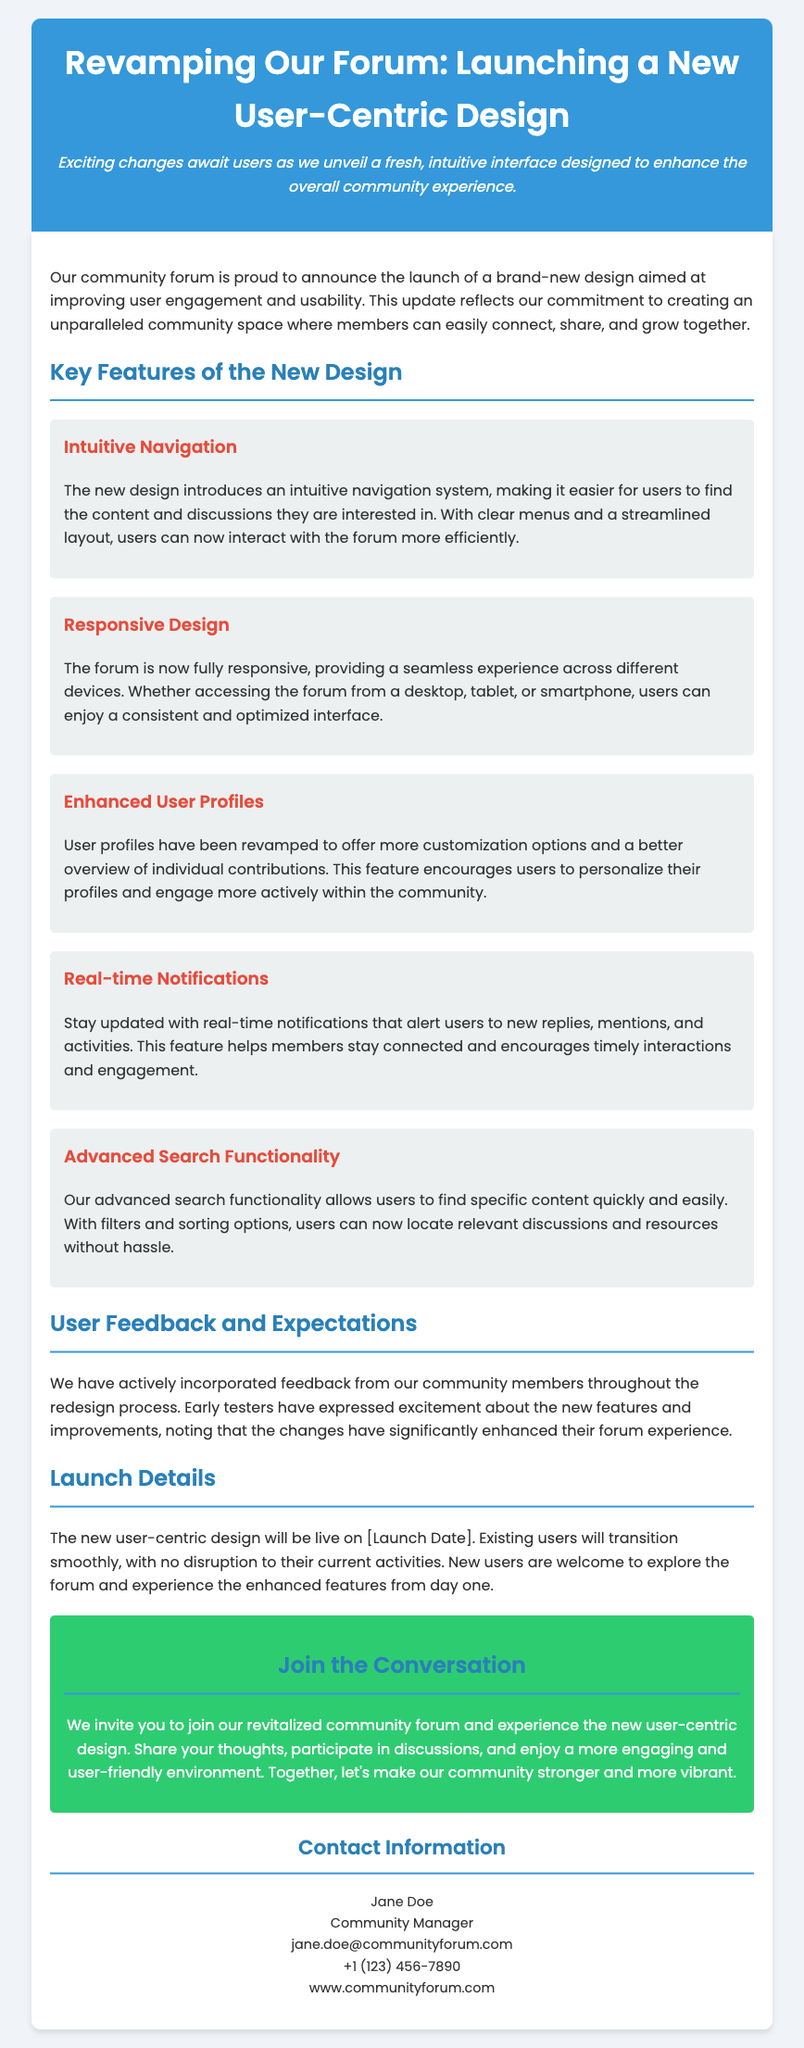What is the title of the press release? The title of the press release is stated clearly at the beginning and reflects the main announcement being made.
Answer: Revamping Our Forum: Launching a New User-Centric Design What is one key feature of the new design? The document lists multiple features in a specific section titled "Key Features of the New Design".
Answer: Intuitive Navigation When will the new design be live? The launch date is mentioned towards the end of the document, specifically in the "Launch Details" section.
Answer: [Launch Date] Who is the community manager? The contact information section provides details about the community manager responsible for the forum.
Answer: Jane Doe What aspect of the design focuses on mobile users? The design includes aspects that improve usability for users on different devices, which is mentioned under a specific feature.
Answer: Responsive Design How have users responded to the new design? User feedback is detailed in the section discussing community responses to the redesign.
Answer: Excitement What aspect encourages users to personalize their profiles? The new features for user profiles are described in detail, emphasizing customization to enhance engagement.
Answer: Enhanced User Profiles What type of notifications will users receive? Notifications that keep users informed about their engagement with the forum are highlighted in one of the features.
Answer: Real-time Notifications 